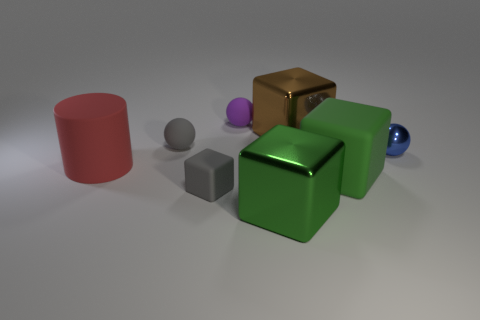Are there the same number of gray rubber cubes on the left side of the tiny matte block and large metallic things in front of the small metal object? Upon reviewing the image, there appears to be one gray rubber cube positioned on the left side of the tiny matte block. In contrast, there are two large metallic objects in front of the small metal sphere, suggesting that the number of gray rubber cubes and large metallic objects is not the same. 